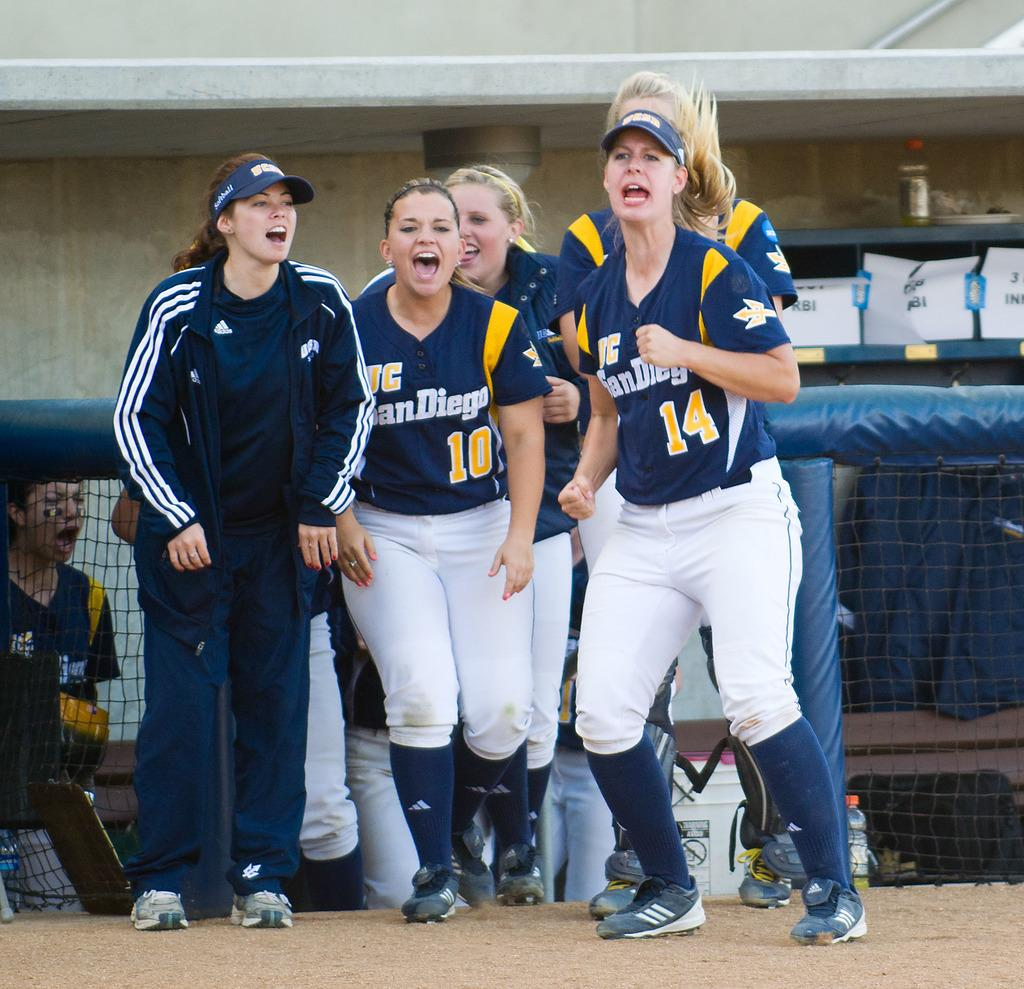<image>
Write a terse but informative summary of the picture. A group of girls in San Diego jerseys. 